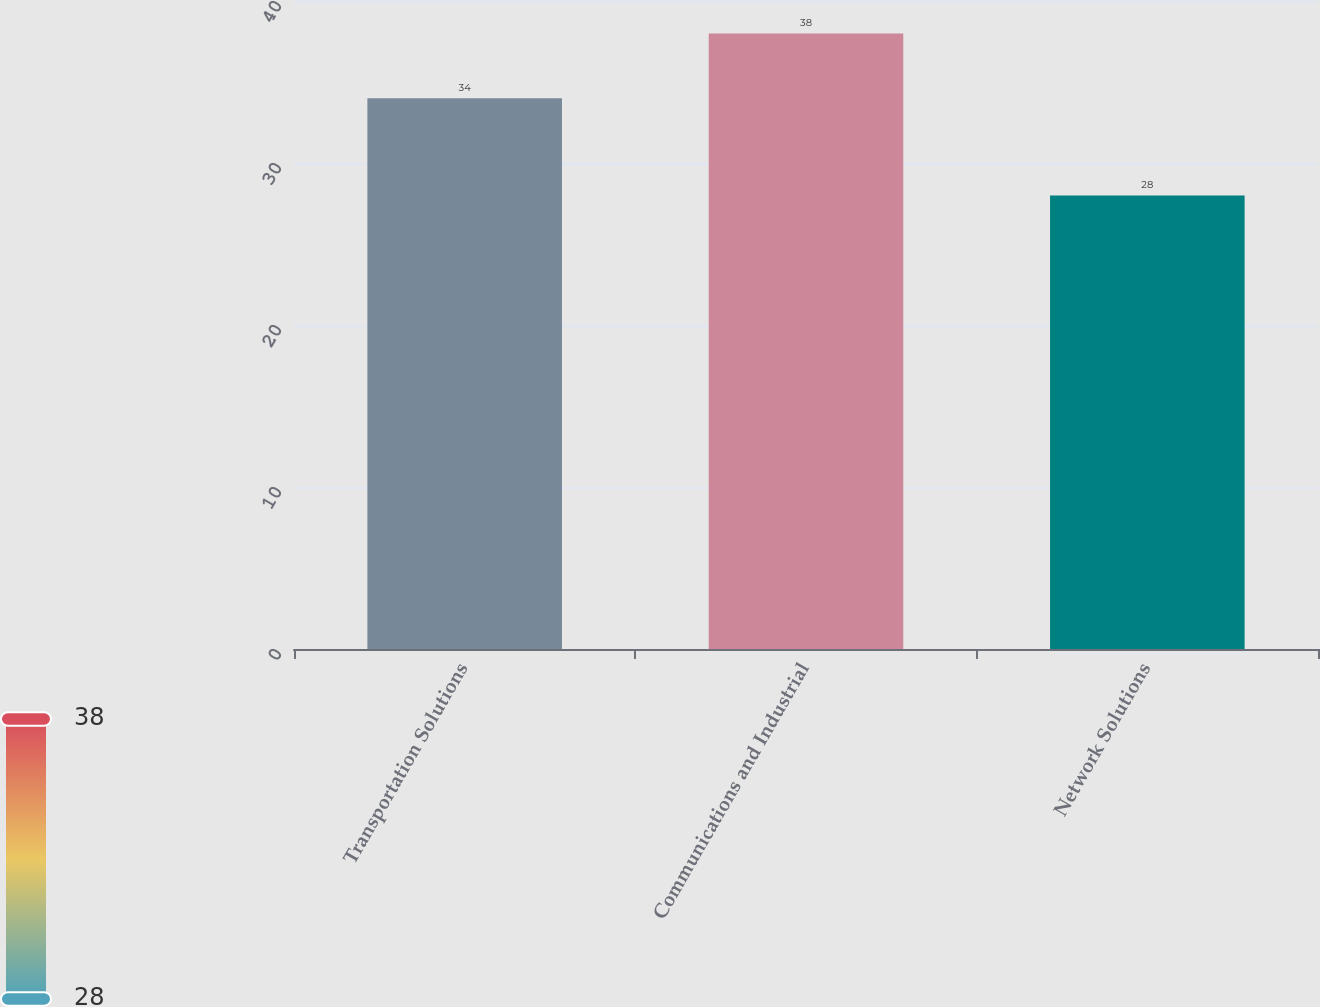Convert chart to OTSL. <chart><loc_0><loc_0><loc_500><loc_500><bar_chart><fcel>Transportation Solutions<fcel>Communications and Industrial<fcel>Network Solutions<nl><fcel>34<fcel>38<fcel>28<nl></chart> 